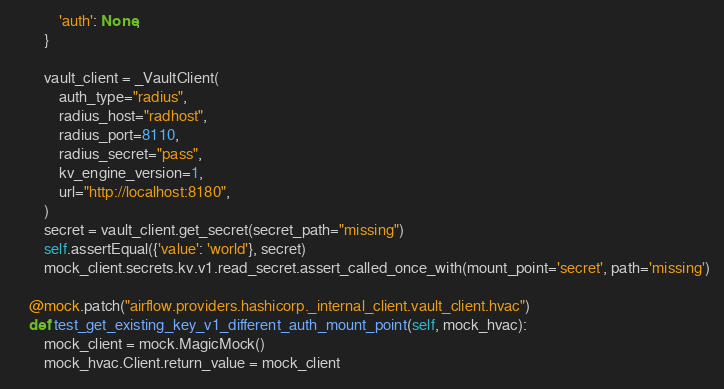<code> <loc_0><loc_0><loc_500><loc_500><_Python_>            'auth': None,
        }

        vault_client = _VaultClient(
            auth_type="radius",
            radius_host="radhost",
            radius_port=8110,
            radius_secret="pass",
            kv_engine_version=1,
            url="http://localhost:8180",
        )
        secret = vault_client.get_secret(secret_path="missing")
        self.assertEqual({'value': 'world'}, secret)
        mock_client.secrets.kv.v1.read_secret.assert_called_once_with(mount_point='secret', path='missing')

    @mock.patch("airflow.providers.hashicorp._internal_client.vault_client.hvac")
    def test_get_existing_key_v1_different_auth_mount_point(self, mock_hvac):
        mock_client = mock.MagicMock()
        mock_hvac.Client.return_value = mock_client
</code> 